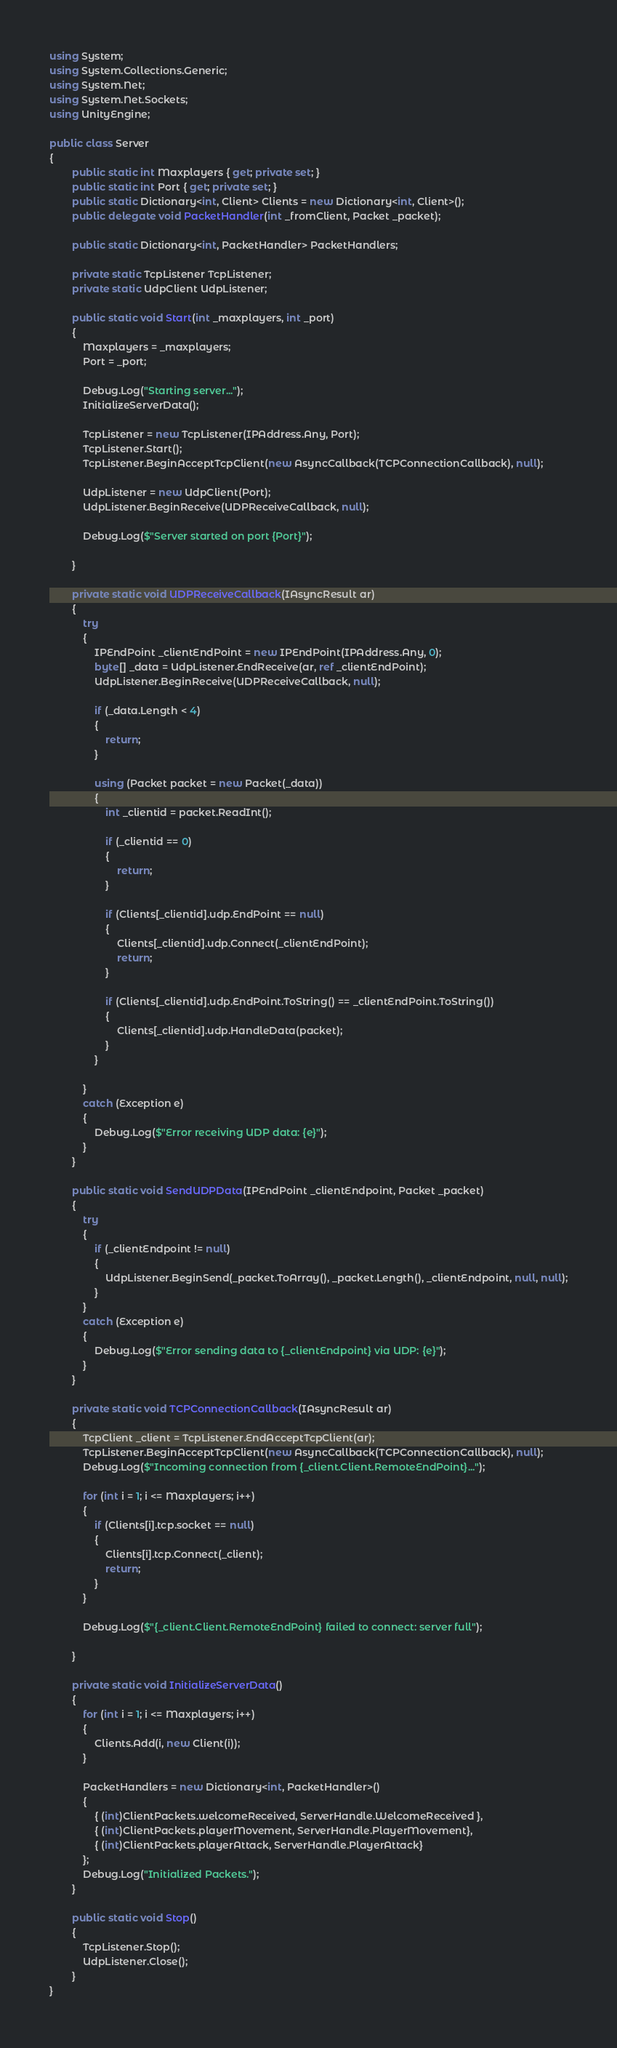Convert code to text. <code><loc_0><loc_0><loc_500><loc_500><_C#_>using System;
using System.Collections.Generic;
using System.Net;
using System.Net.Sockets;
using UnityEngine;

public class Server
{
        public static int Maxplayers { get; private set; }
        public static int Port { get; private set; }
        public static Dictionary<int, Client> Clients = new Dictionary<int, Client>();
        public delegate void PacketHandler(int _fromClient, Packet _packet);

        public static Dictionary<int, PacketHandler> PacketHandlers;
        
        private static TcpListener TcpListener;
        private static UdpClient UdpListener;

        public static void Start(int _maxplayers, int _port)
        {
            Maxplayers = _maxplayers;
            Port = _port;
            
            Debug.Log("Starting server...");
            InitializeServerData();
            
            TcpListener = new TcpListener(IPAddress.Any, Port);
            TcpListener.Start();
            TcpListener.BeginAcceptTcpClient(new AsyncCallback(TCPConnectionCallback), null);

            UdpListener = new UdpClient(Port);
            UdpListener.BeginReceive(UDPReceiveCallback, null);
            
            Debug.Log($"Server started on port {Port}");

        }

        private static void UDPReceiveCallback(IAsyncResult ar)
        {
            try
            {
                IPEndPoint _clientEndPoint = new IPEndPoint(IPAddress.Any, 0);
                byte[] _data = UdpListener.EndReceive(ar, ref _clientEndPoint);
                UdpListener.BeginReceive(UDPReceiveCallback, null);

                if (_data.Length < 4)
                {
                    return;
                }

                using (Packet packet = new Packet(_data))
                {
                    int _clientid = packet.ReadInt();

                    if (_clientid == 0)
                    {
                        return;
                    }

                    if (Clients[_clientid].udp.EndPoint == null)
                    {
                        Clients[_clientid].udp.Connect(_clientEndPoint);
                        return;
                    }

                    if (Clients[_clientid].udp.EndPoint.ToString() == _clientEndPoint.ToString())
                    {
                        Clients[_clientid].udp.HandleData(packet);
                    }
                }
                
            }
            catch (Exception e)
            {
                Debug.Log($"Error receiving UDP data: {e}");
            }
        }

        public static void SendUDPData(IPEndPoint _clientEndpoint, Packet _packet)
        {
            try
            {
                if (_clientEndpoint != null)
                {
                    UdpListener.BeginSend(_packet.ToArray(), _packet.Length(), _clientEndpoint, null, null);
                }
            }
            catch (Exception e)
            {
                Debug.Log($"Error sending data to {_clientEndpoint} via UDP: {e}");
            }
        }

        private static void TCPConnectionCallback(IAsyncResult ar)
        {
            TcpClient _client = TcpListener.EndAcceptTcpClient(ar);
            TcpListener.BeginAcceptTcpClient(new AsyncCallback(TCPConnectionCallback), null);
            Debug.Log($"Incoming connection from {_client.Client.RemoteEndPoint}...");

            for (int i = 1; i <= Maxplayers; i++)
            {
                if (Clients[i].tcp.socket == null)
                {
                    Clients[i].tcp.Connect(_client);
                    return;
                }
            }

            Debug.Log($"{_client.Client.RemoteEndPoint} failed to connect: server full");
            
        }

        private static void InitializeServerData()
        {
            for (int i = 1; i <= Maxplayers; i++)
            {
                Clients.Add(i, new Client(i));
            }

            PacketHandlers = new Dictionary<int, PacketHandler>()
            {
                { (int)ClientPackets.welcomeReceived, ServerHandle.WelcomeReceived },
                { (int)ClientPackets.playerMovement, ServerHandle.PlayerMovement},
                { (int)ClientPackets.playerAttack, ServerHandle.PlayerAttack}
            };
            Debug.Log("Initialized Packets.");
        }

        public static void Stop()
        {
            TcpListener.Stop();
            UdpListener.Close();
        }
}
</code> 